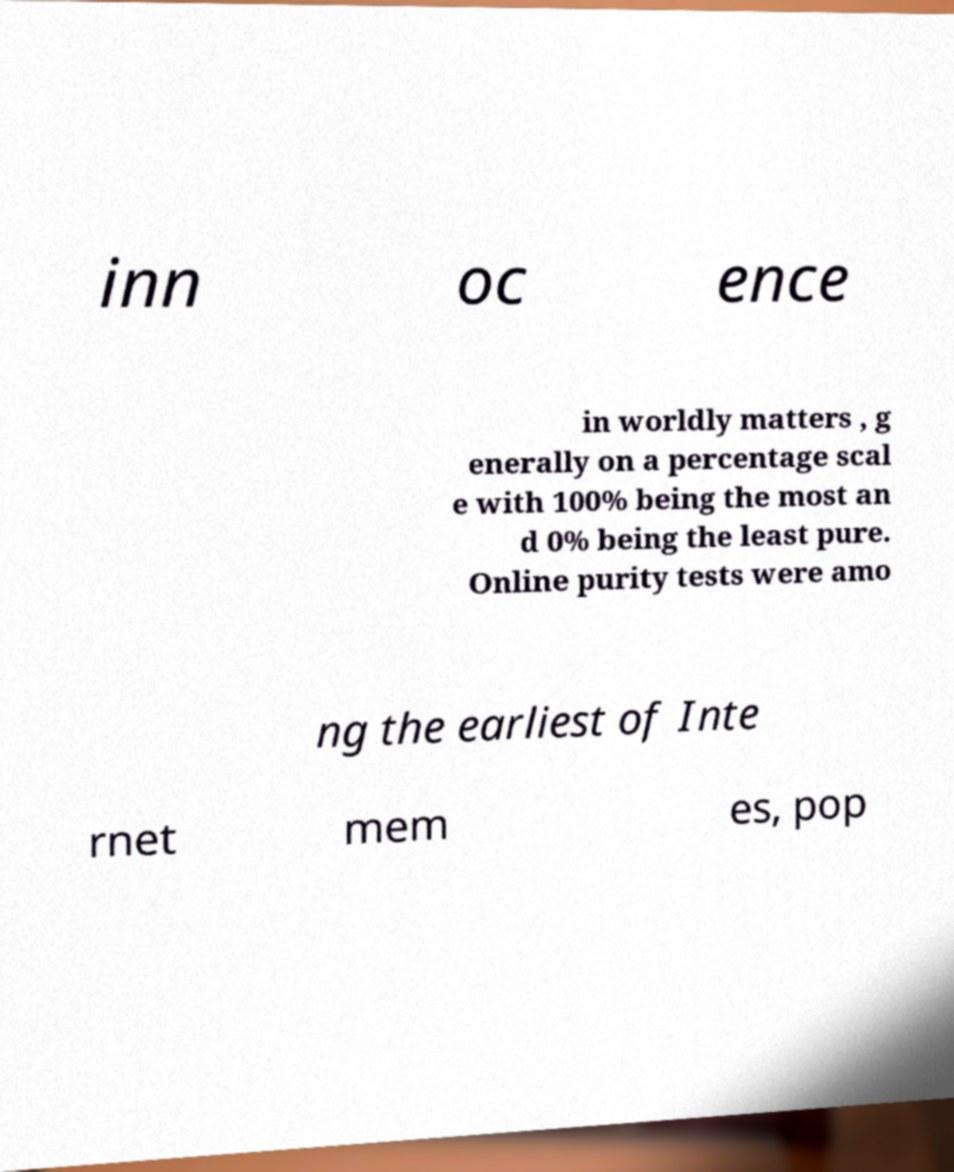Can you accurately transcribe the text from the provided image for me? inn oc ence in worldly matters , g enerally on a percentage scal e with 100% being the most an d 0% being the least pure. Online purity tests were amo ng the earliest of Inte rnet mem es, pop 